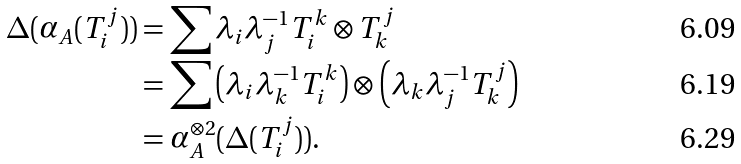Convert formula to latex. <formula><loc_0><loc_0><loc_500><loc_500>\Delta ( \alpha _ { A } ( T _ { i } ^ { j } ) ) & = \sum \lambda _ { i } \lambda _ { j } ^ { - 1 } T _ { i } ^ { k } \otimes T _ { k } ^ { j } \\ & = \sum \left ( \lambda _ { i } \lambda _ { k } ^ { - 1 } T _ { i } ^ { k } \right ) \otimes \left ( \lambda _ { k } \lambda _ { j } ^ { - 1 } T _ { k } ^ { j } \right ) \\ & = \alpha _ { A } ^ { \otimes 2 } ( \Delta ( T _ { i } ^ { j } ) ) .</formula> 